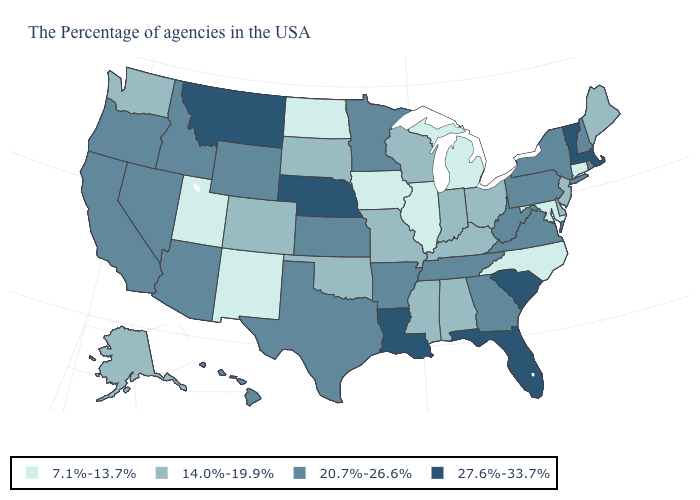Name the states that have a value in the range 27.6%-33.7%?
Concise answer only. Massachusetts, Vermont, South Carolina, Florida, Louisiana, Nebraska, Montana. Which states hav the highest value in the MidWest?
Be succinct. Nebraska. What is the value of Vermont?
Keep it brief. 27.6%-33.7%. Which states have the lowest value in the West?
Keep it brief. New Mexico, Utah. Does South Dakota have a lower value than Connecticut?
Give a very brief answer. No. Does South Carolina have a higher value than Maine?
Concise answer only. Yes. Name the states that have a value in the range 20.7%-26.6%?
Keep it brief. Rhode Island, New Hampshire, New York, Pennsylvania, Virginia, West Virginia, Georgia, Tennessee, Arkansas, Minnesota, Kansas, Texas, Wyoming, Arizona, Idaho, Nevada, California, Oregon, Hawaii. Does West Virginia have a higher value than Oklahoma?
Short answer required. Yes. What is the lowest value in states that border Arkansas?
Keep it brief. 14.0%-19.9%. Which states hav the highest value in the Northeast?
Concise answer only. Massachusetts, Vermont. What is the value of California?
Quick response, please. 20.7%-26.6%. Which states hav the highest value in the MidWest?
Short answer required. Nebraska. Among the states that border Pennsylvania , which have the lowest value?
Answer briefly. Maryland. Name the states that have a value in the range 27.6%-33.7%?
Write a very short answer. Massachusetts, Vermont, South Carolina, Florida, Louisiana, Nebraska, Montana. Which states have the highest value in the USA?
Be succinct. Massachusetts, Vermont, South Carolina, Florida, Louisiana, Nebraska, Montana. 